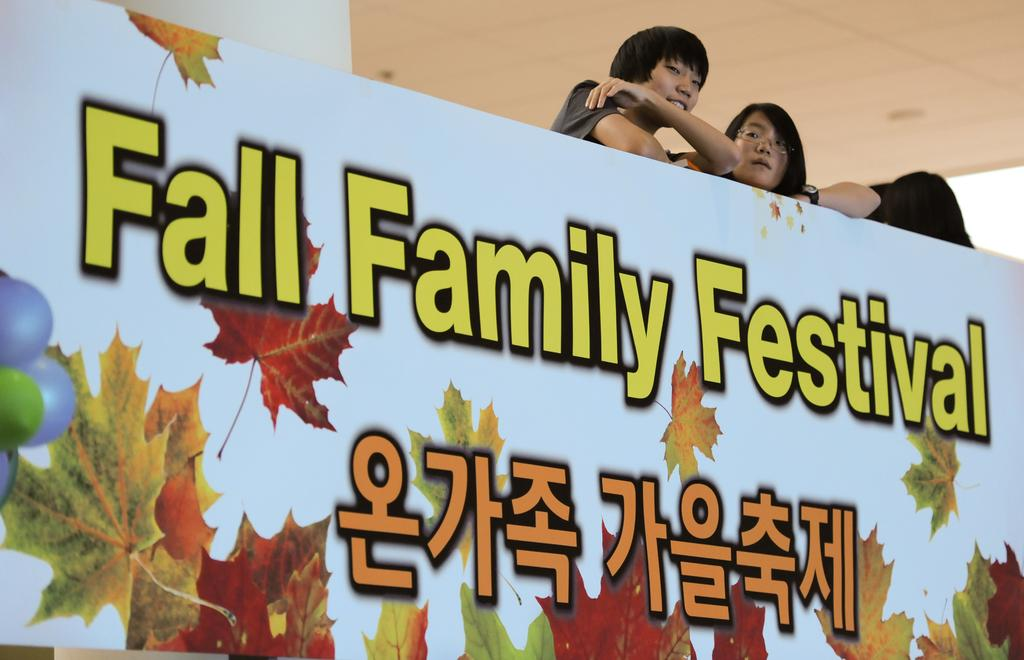What is on the wall in the image? There is text on the wall in the image. Can you describe the people behind the wall? There are two people standing behind the wall. What adjustment does the aunt make to the wall in the image? There is no aunt present in the image, and no adjustment is being made to the wall. 